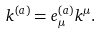<formula> <loc_0><loc_0><loc_500><loc_500>k ^ { ( a ) } = e ^ { ( a ) } _ { \mu } k ^ { \mu } .</formula> 